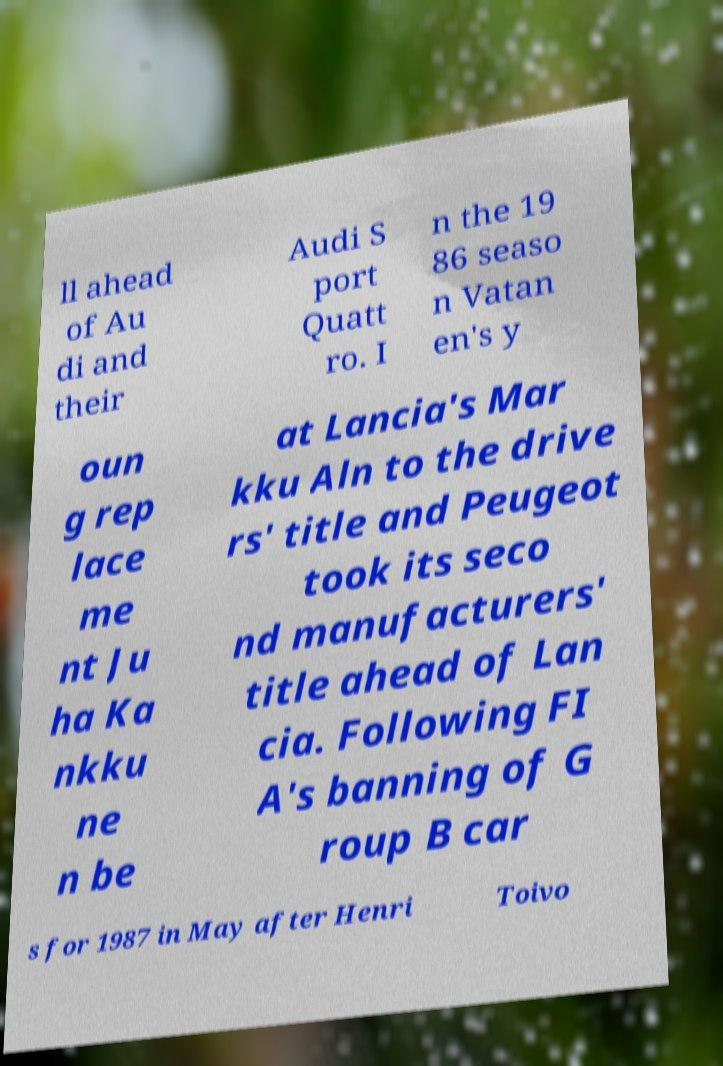What messages or text are displayed in this image? I need them in a readable, typed format. ll ahead of Au di and their Audi S port Quatt ro. I n the 19 86 seaso n Vatan en's y oun g rep lace me nt Ju ha Ka nkku ne n be at Lancia's Mar kku Aln to the drive rs' title and Peugeot took its seco nd manufacturers' title ahead of Lan cia. Following FI A's banning of G roup B car s for 1987 in May after Henri Toivo 